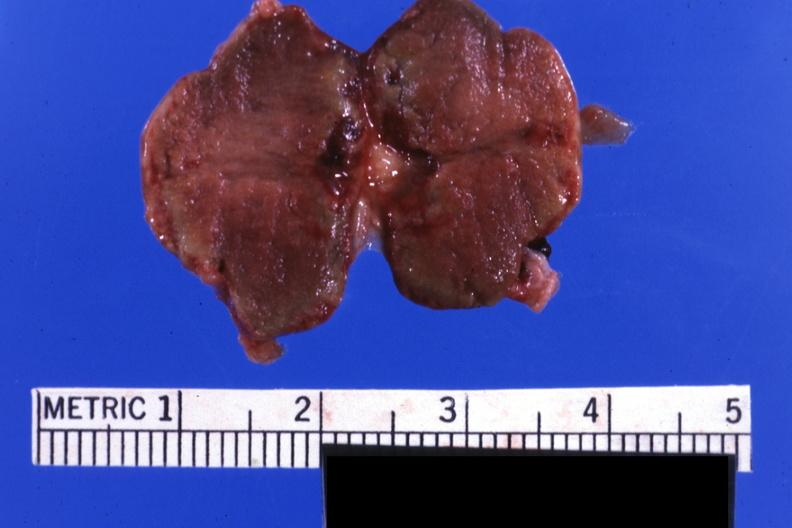what is present?
Answer the question using a single word or phrase. Hemorrhage associated with placental abruption 